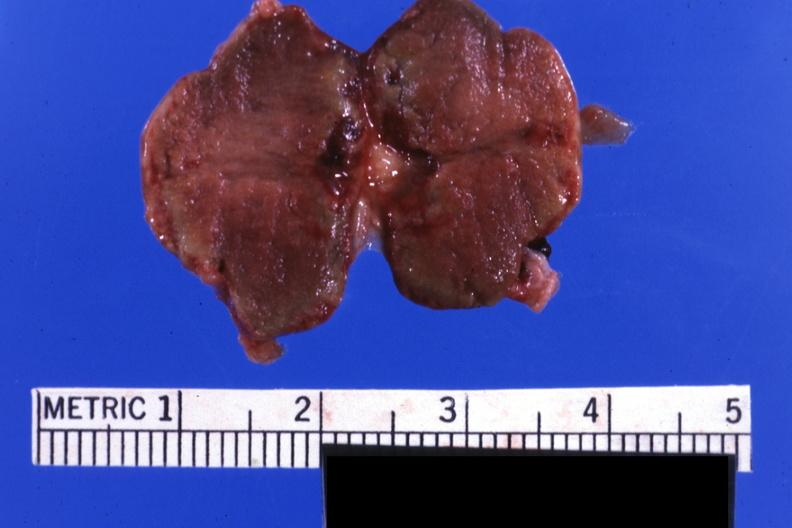what is present?
Answer the question using a single word or phrase. Hemorrhage associated with placental abruption 